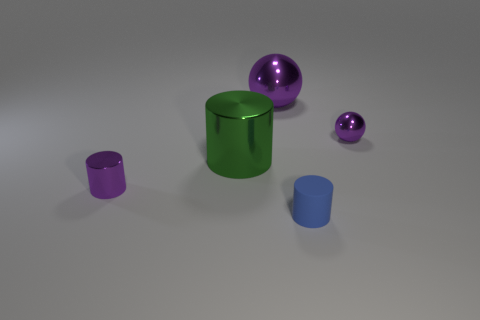Add 3 shiny cylinders. How many objects exist? 8 Subtract all cylinders. How many objects are left? 2 Add 3 tiny blue matte balls. How many tiny blue matte balls exist? 3 Subtract all small purple metallic cylinders. How many cylinders are left? 2 Subtract 0 blue spheres. How many objects are left? 5 Subtract 1 balls. How many balls are left? 1 Subtract all blue cylinders. Subtract all blue blocks. How many cylinders are left? 2 Subtract all brown spheres. How many purple cylinders are left? 1 Subtract all metallic cylinders. Subtract all green shiny cylinders. How many objects are left? 2 Add 3 big green shiny cylinders. How many big green shiny cylinders are left? 4 